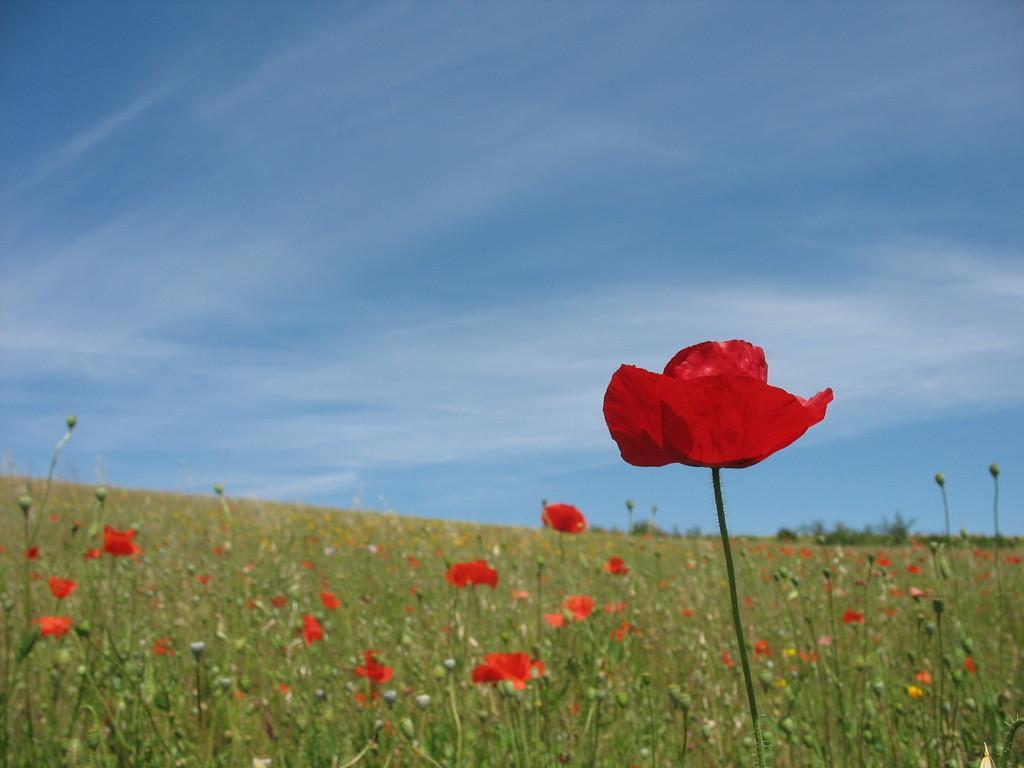Please provide a concise description of this image. In this image there are plants. There are buds and flowers to the plants. At the top there is the sky. 